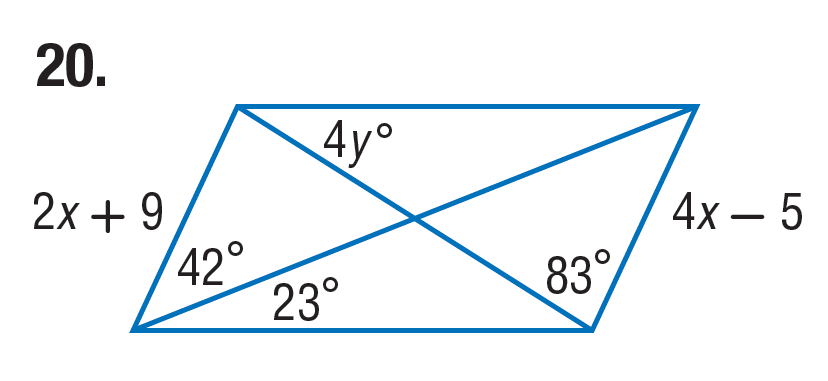Answer the mathemtical geometry problem and directly provide the correct option letter.
Question: Find y in the parallelogram.
Choices: A: 8 B: 15 C: 16 D: 32 A 